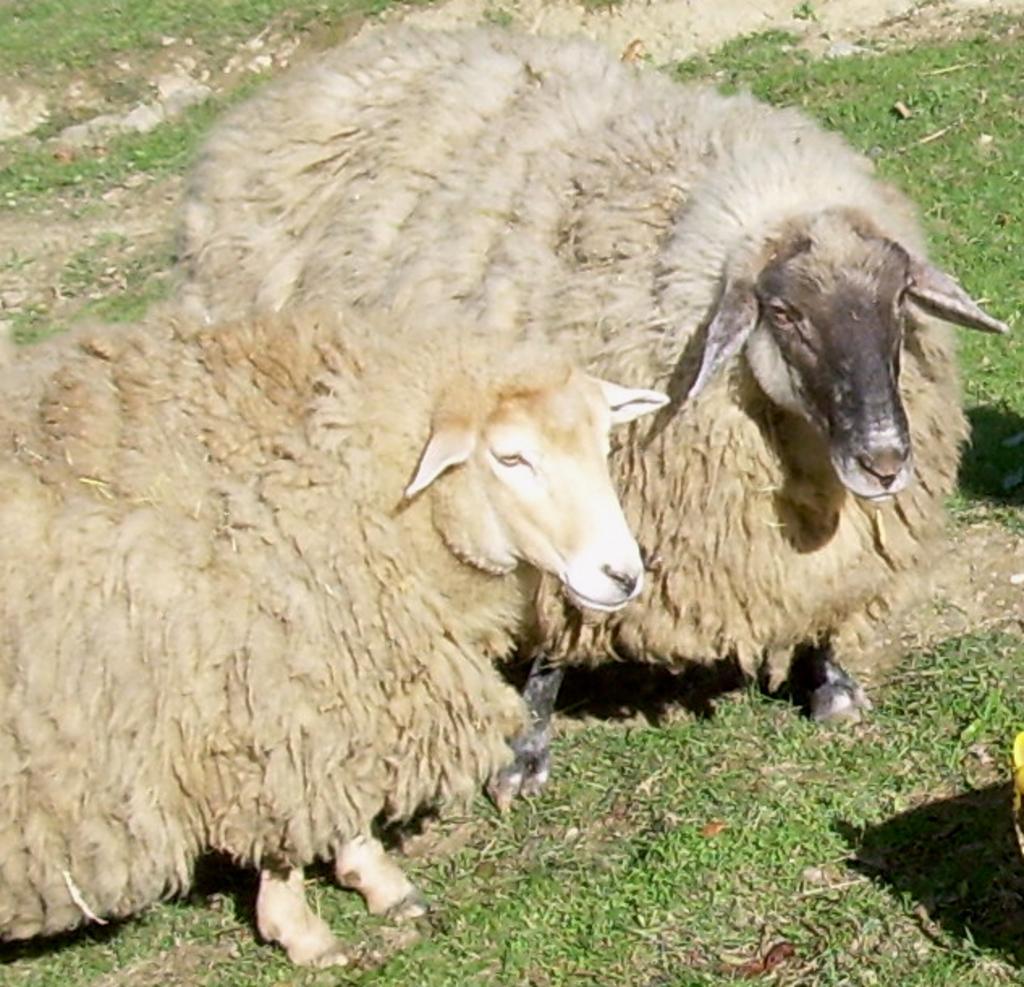In one or two sentences, can you explain what this image depicts? We can see sheeps on the grass. 